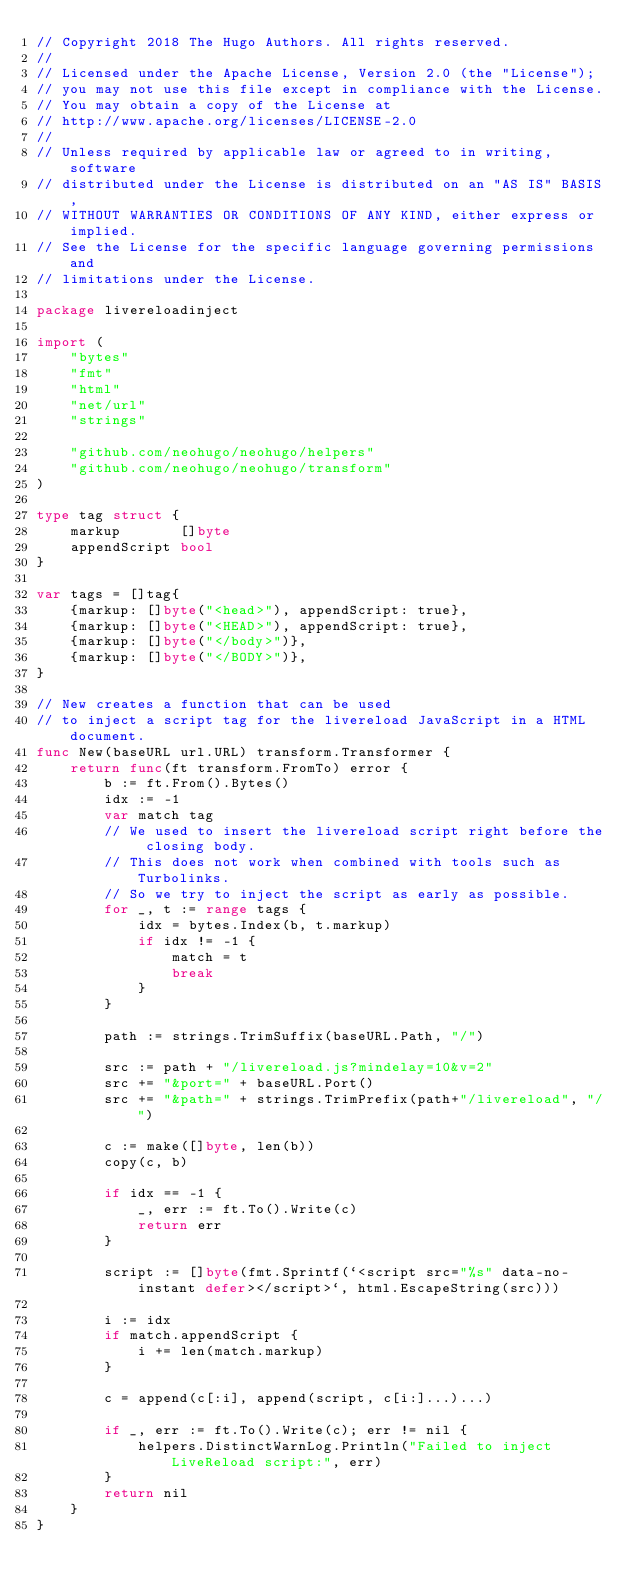Convert code to text. <code><loc_0><loc_0><loc_500><loc_500><_Go_>// Copyright 2018 The Hugo Authors. All rights reserved.
//
// Licensed under the Apache License, Version 2.0 (the "License");
// you may not use this file except in compliance with the License.
// You may obtain a copy of the License at
// http://www.apache.org/licenses/LICENSE-2.0
//
// Unless required by applicable law or agreed to in writing, software
// distributed under the License is distributed on an "AS IS" BASIS,
// WITHOUT WARRANTIES OR CONDITIONS OF ANY KIND, either express or implied.
// See the License for the specific language governing permissions and
// limitations under the License.

package livereloadinject

import (
	"bytes"
	"fmt"
	"html"
	"net/url"
	"strings"

	"github.com/neohugo/neohugo/helpers"
	"github.com/neohugo/neohugo/transform"
)

type tag struct {
	markup       []byte
	appendScript bool
}

var tags = []tag{
	{markup: []byte("<head>"), appendScript: true},
	{markup: []byte("<HEAD>"), appendScript: true},
	{markup: []byte("</body>")},
	{markup: []byte("</BODY>")},
}

// New creates a function that can be used
// to inject a script tag for the livereload JavaScript in a HTML document.
func New(baseURL url.URL) transform.Transformer {
	return func(ft transform.FromTo) error {
		b := ft.From().Bytes()
		idx := -1
		var match tag
		// We used to insert the livereload script right before the closing body.
		// This does not work when combined with tools such as Turbolinks.
		// So we try to inject the script as early as possible.
		for _, t := range tags {
			idx = bytes.Index(b, t.markup)
			if idx != -1 {
				match = t
				break
			}
		}

		path := strings.TrimSuffix(baseURL.Path, "/")

		src := path + "/livereload.js?mindelay=10&v=2"
		src += "&port=" + baseURL.Port()
		src += "&path=" + strings.TrimPrefix(path+"/livereload", "/")

		c := make([]byte, len(b))
		copy(c, b)

		if idx == -1 {
			_, err := ft.To().Write(c)
			return err
		}

		script := []byte(fmt.Sprintf(`<script src="%s" data-no-instant defer></script>`, html.EscapeString(src)))

		i := idx
		if match.appendScript {
			i += len(match.markup)
		}

		c = append(c[:i], append(script, c[i:]...)...)

		if _, err := ft.To().Write(c); err != nil {
			helpers.DistinctWarnLog.Println("Failed to inject LiveReload script:", err)
		}
		return nil
	}
}
</code> 